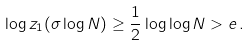<formula> <loc_0><loc_0><loc_500><loc_500>\log z _ { 1 } ( \sigma \log N ) \geq \frac { 1 } { 2 } \log \log N > e \, .</formula> 